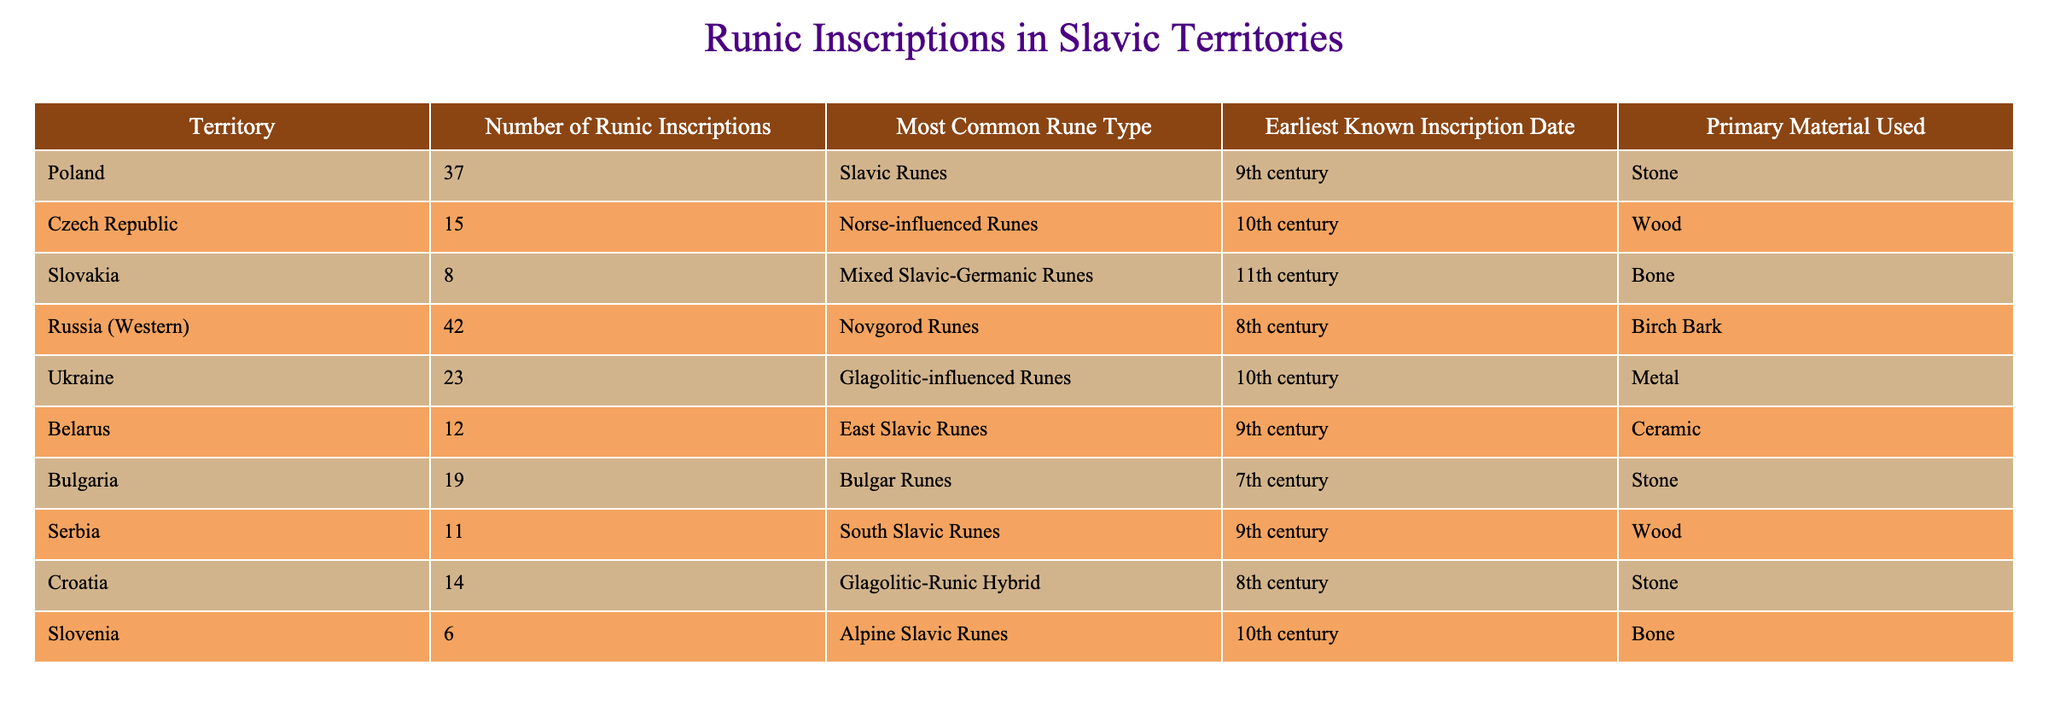What is the territory with the highest number of runic inscriptions? By looking at the "Number of Runic Inscriptions" column, I find that Russia (Western) has 42 inscriptions, which is greater than any other territory listed.
Answer: Russia (Western) How many runic inscriptions are found in Poland? The table directly shows that the "Number of Runic Inscriptions" for Poland is 37.
Answer: 37 What is the earliest known inscription date from Belarus? The table indicates that Belarus has an "Earliest Known Inscription Date" of the 9th century.
Answer: 9th century Is the most common rune type in Ukraine Glagolitic-influenced Runes? The table lists the "Most Common Rune Type" for Ukraine as Glagolitic-influenced Runes, which confirms that this fact is true.
Answer: Yes What is the average number of runic inscriptions in the Czech Republic and Slovakia combined? Adding the values from the "Number of Runic Inscriptions" for Czech Republic (15) and Slovakia (8), I get 15 + 8 = 23. Dividing this sum by 2 gives me an average of 23/2 = 11.5.
Answer: 11.5 Which material is most commonly used for runic inscriptions in Croatia? The table shows that the "Primary Material Used" for Croatia is Stone.
Answer: Stone Is there any territory with more than 20 runic inscriptions? By reviewing the "Number of Runic Inscriptions", it appears that Russia (Western), Poland, and Ukraine all have more than 20 inscriptions, confirming that some territories exceed this number.
Answer: Yes What is the difference in the number of runic inscriptions between Bulgaria and Serbia? From the table, Bulgaria has 19 inscriptions and Serbia has 11. The difference can be calculated as 19 - 11 = 8.
Answer: 8 What rune types are used in Slovakia and Ukraine? The table indicates that Slovakia uses Mixed Slavic-Germanic Runes and Ukraine uses Glagolitic-influenced Runes. Thus, both rune types can be summarized from their respective rows.
Answer: Mixed Slavic-Germanic Runes and Glagolitic-influenced Runes 